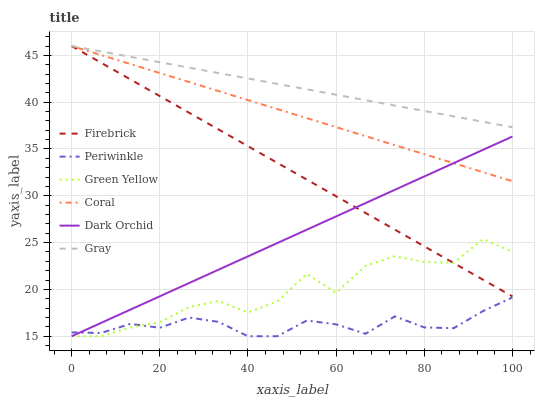Does Periwinkle have the minimum area under the curve?
Answer yes or no. Yes. Does Gray have the maximum area under the curve?
Answer yes or no. Yes. Does Firebrick have the minimum area under the curve?
Answer yes or no. No. Does Firebrick have the maximum area under the curve?
Answer yes or no. No. Is Coral the smoothest?
Answer yes or no. Yes. Is Green Yellow the roughest?
Answer yes or no. Yes. Is Firebrick the smoothest?
Answer yes or no. No. Is Firebrick the roughest?
Answer yes or no. No. Does Firebrick have the lowest value?
Answer yes or no. No. Does Coral have the highest value?
Answer yes or no. Yes. Does Dark Orchid have the highest value?
Answer yes or no. No. Is Periwinkle less than Coral?
Answer yes or no. Yes. Is Firebrick greater than Periwinkle?
Answer yes or no. Yes. Does Coral intersect Gray?
Answer yes or no. Yes. Is Coral less than Gray?
Answer yes or no. No. Is Coral greater than Gray?
Answer yes or no. No. Does Periwinkle intersect Coral?
Answer yes or no. No. 